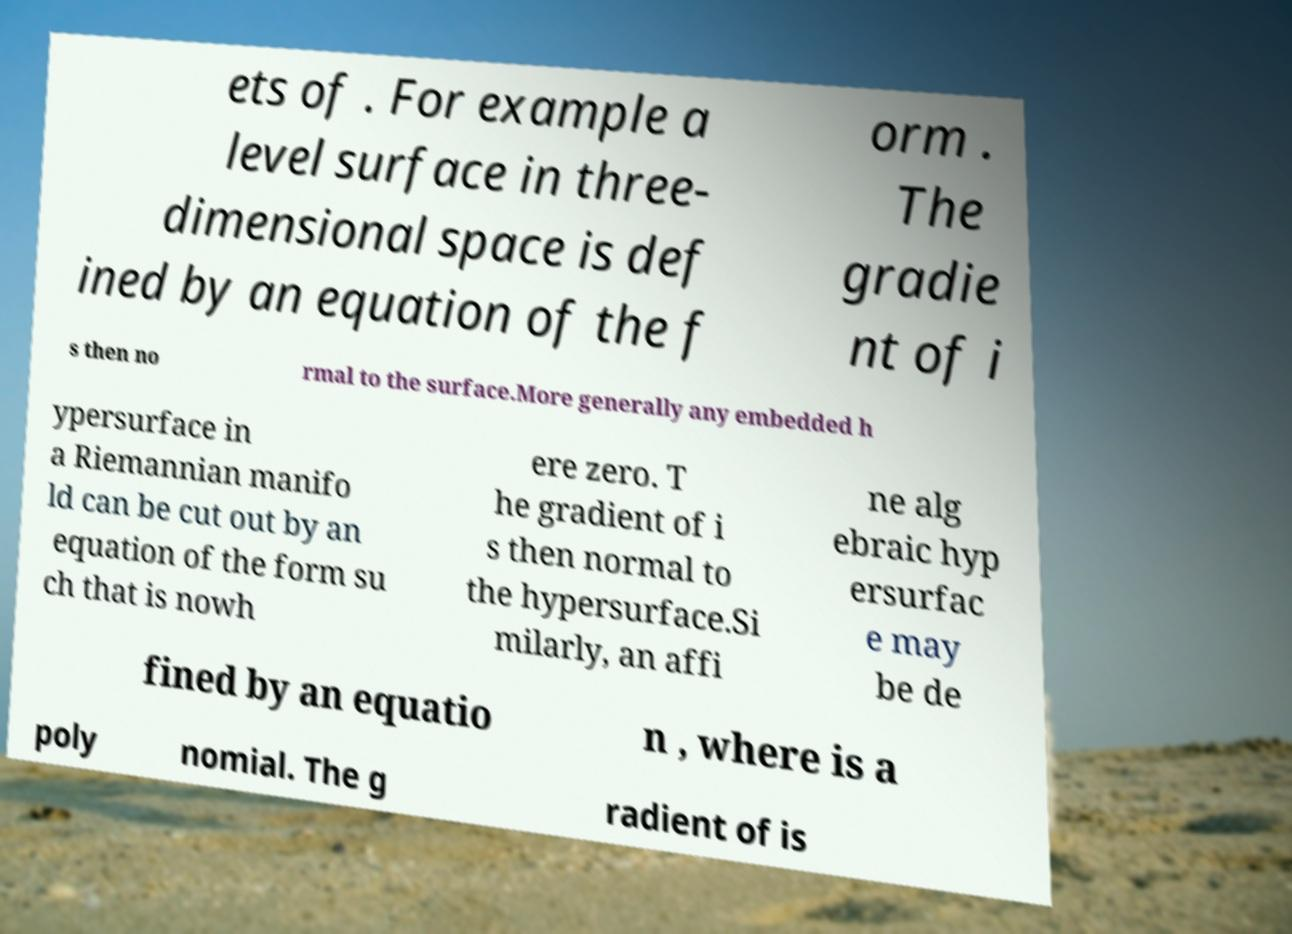What messages or text are displayed in this image? I need them in a readable, typed format. ets of . For example a level surface in three- dimensional space is def ined by an equation of the f orm . The gradie nt of i s then no rmal to the surface.More generally any embedded h ypersurface in a Riemannian manifo ld can be cut out by an equation of the form su ch that is nowh ere zero. T he gradient of i s then normal to the hypersurface.Si milarly, an affi ne alg ebraic hyp ersurfac e may be de fined by an equatio n , where is a poly nomial. The g radient of is 